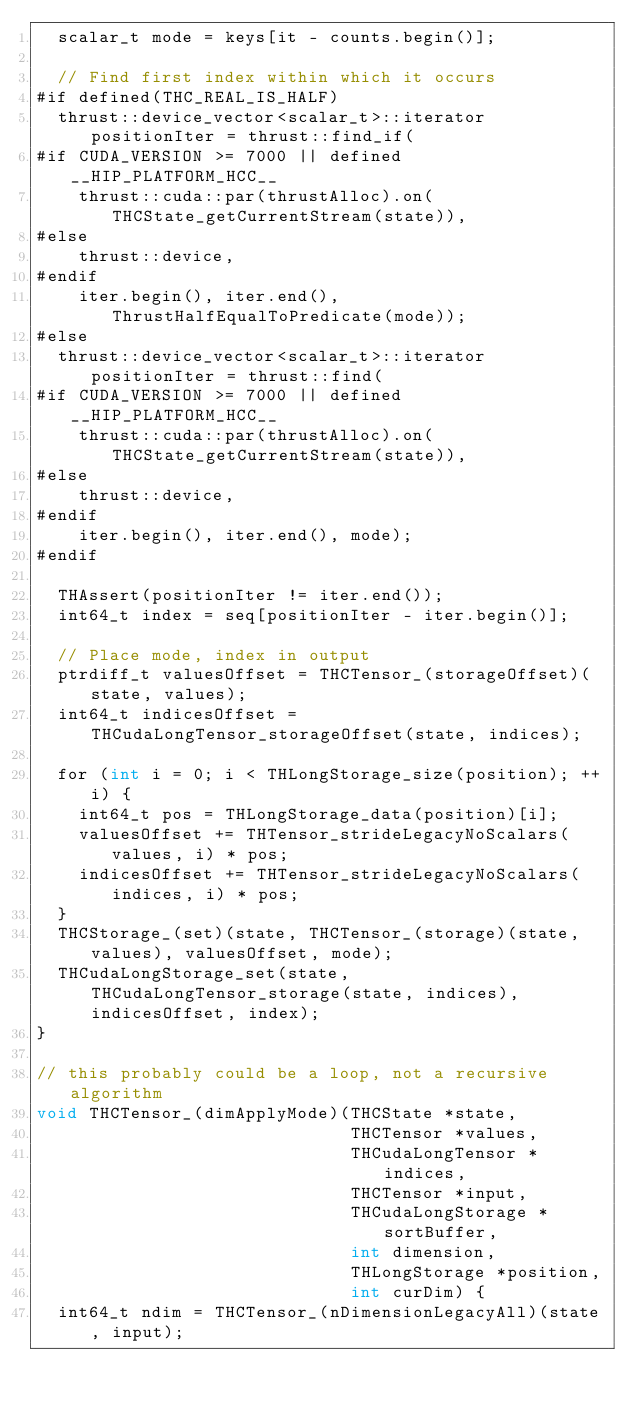<code> <loc_0><loc_0><loc_500><loc_500><_Cuda_>  scalar_t mode = keys[it - counts.begin()];

  // Find first index within which it occurs
#if defined(THC_REAL_IS_HALF)
  thrust::device_vector<scalar_t>::iterator positionIter = thrust::find_if(
#if CUDA_VERSION >= 7000 || defined __HIP_PLATFORM_HCC__
    thrust::cuda::par(thrustAlloc).on(THCState_getCurrentStream(state)),
#else
    thrust::device,
#endif
    iter.begin(), iter.end(), ThrustHalfEqualToPredicate(mode));
#else
  thrust::device_vector<scalar_t>::iterator positionIter = thrust::find(
#if CUDA_VERSION >= 7000 || defined __HIP_PLATFORM_HCC__
    thrust::cuda::par(thrustAlloc).on(THCState_getCurrentStream(state)),
#else
    thrust::device,
#endif
    iter.begin(), iter.end(), mode);
#endif

  THAssert(positionIter != iter.end());
  int64_t index = seq[positionIter - iter.begin()];

  // Place mode, index in output
  ptrdiff_t valuesOffset = THCTensor_(storageOffset)(state, values);
  int64_t indicesOffset = THCudaLongTensor_storageOffset(state, indices);

  for (int i = 0; i < THLongStorage_size(position); ++i) {
    int64_t pos = THLongStorage_data(position)[i];
    valuesOffset += THTensor_strideLegacyNoScalars(values, i) * pos;
    indicesOffset += THTensor_strideLegacyNoScalars(indices, i) * pos;
  }
  THCStorage_(set)(state, THCTensor_(storage)(state, values), valuesOffset, mode);
  THCudaLongStorage_set(state, THCudaLongTensor_storage(state, indices), indicesOffset, index);
}

// this probably could be a loop, not a recursive algorithm
void THCTensor_(dimApplyMode)(THCState *state,
                              THCTensor *values,
                              THCudaLongTensor *indices,
                              THCTensor *input,
                              THCudaLongStorage *sortBuffer,
                              int dimension,
                              THLongStorage *position,
                              int curDim) {
  int64_t ndim = THCTensor_(nDimensionLegacyAll)(state, input);
</code> 